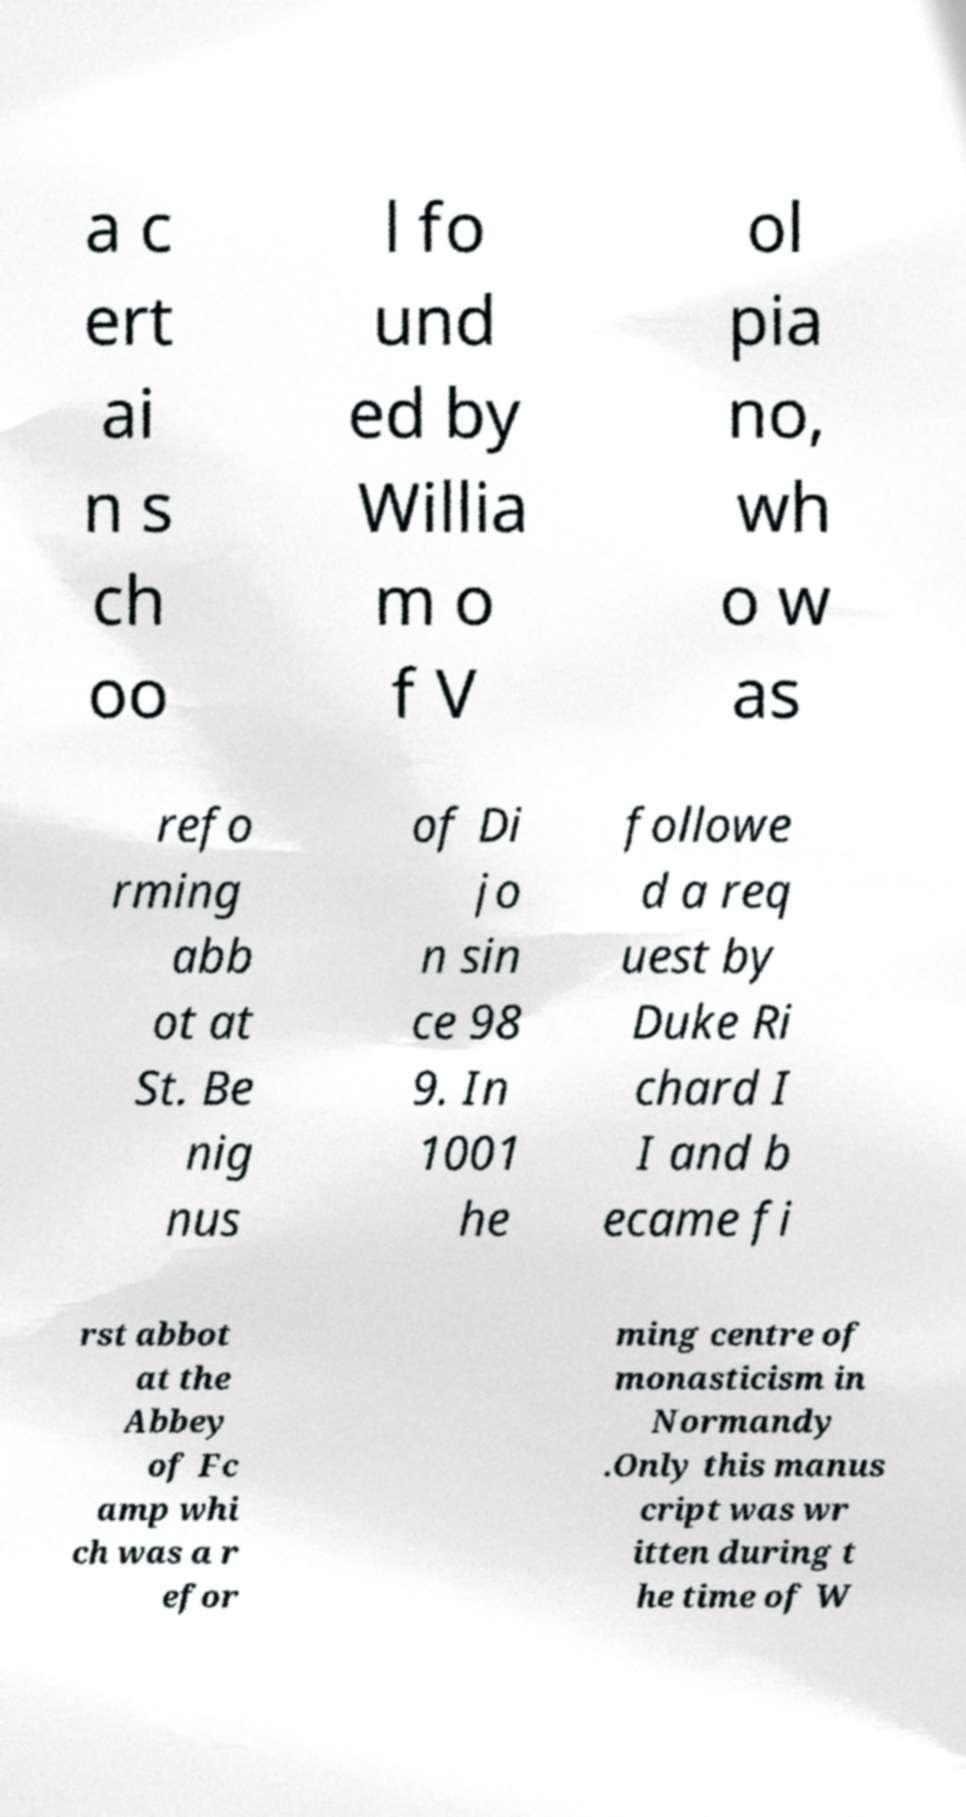I need the written content from this picture converted into text. Can you do that? a c ert ai n s ch oo l fo und ed by Willia m o f V ol pia no, wh o w as refo rming abb ot at St. Be nig nus of Di jo n sin ce 98 9. In 1001 he followe d a req uest by Duke Ri chard I I and b ecame fi rst abbot at the Abbey of Fc amp whi ch was a r efor ming centre of monasticism in Normandy .Only this manus cript was wr itten during t he time of W 